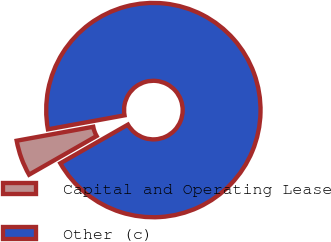Convert chart. <chart><loc_0><loc_0><loc_500><loc_500><pie_chart><fcel>Capital and Operating Lease<fcel>Other (c)<nl><fcel>5.39%<fcel>94.61%<nl></chart> 